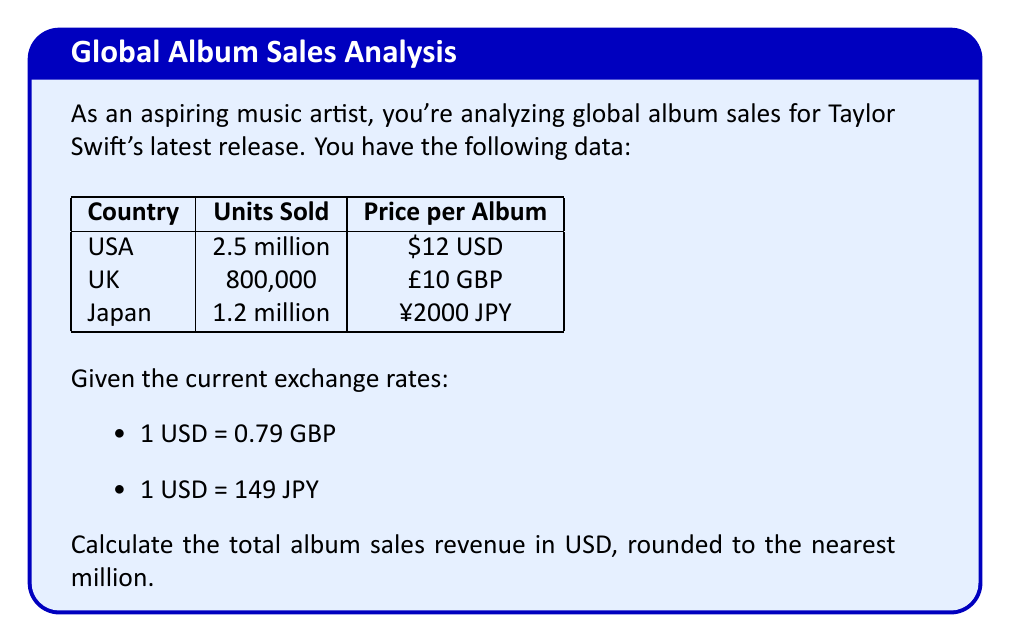What is the answer to this math problem? Let's break this down step-by-step:

1. Calculate USA sales in USD:
   $2,500,000 \times \$12 = \$30,000,000$ USD

2. Convert UK sales to USD:
   - First, calculate total in GBP: $800,000 \times £10 = £8,000,000$ GBP
   - Convert to USD: $£8,000,000 \div 0.79 = \$10,126,582.28$ USD

3. Convert Japan sales to USD:
   - First, calculate total in JPY: $1,200,000 \times ¥2000 = ¥2,400,000,000$ JPY
   - Convert to USD: $¥2,400,000,000 \div 149 = \$16,107,382.55$ USD

4. Sum up all sales in USD:
   $\$30,000,000 + \$10,126,582.28 + \$16,107,382.55 = \$56,233,964.83$ USD

5. Round to the nearest million:
   $\$56,233,964.83 \approx \$56,000,000$ USD
Answer: $56 million USD 